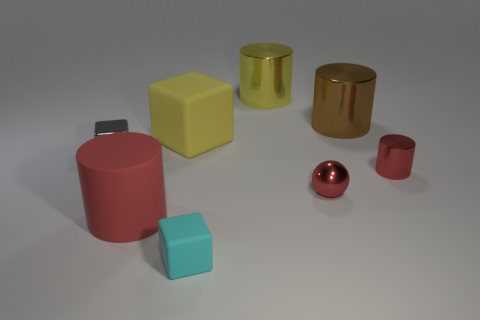Subtract all yellow spheres. How many red cylinders are left? 2 Subtract all large yellow metal cylinders. How many cylinders are left? 3 Subtract all brown cylinders. How many cylinders are left? 3 Add 2 small cyan cubes. How many objects exist? 10 Subtract 1 blocks. How many blocks are left? 2 Subtract all blocks. How many objects are left? 5 Subtract all gray cylinders. Subtract all gray spheres. How many cylinders are left? 4 Subtract 1 red spheres. How many objects are left? 7 Subtract all large cylinders. Subtract all large yellow blocks. How many objects are left? 4 Add 5 brown things. How many brown things are left? 6 